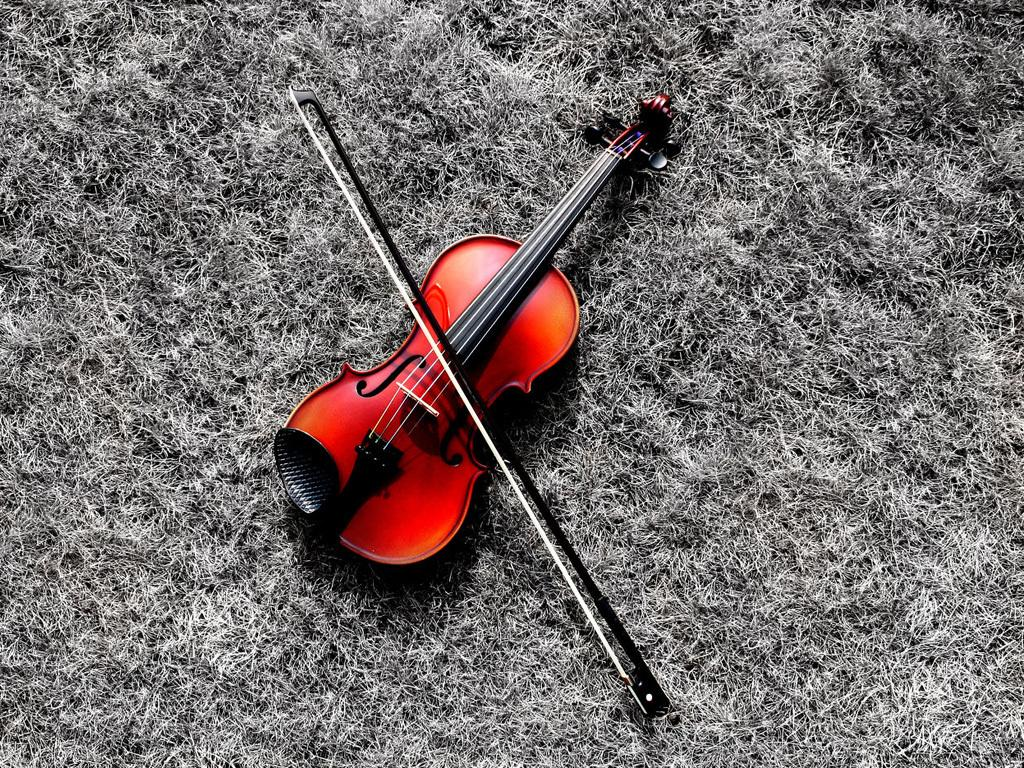What type of object is the main subject in the image? There is a musical instrument in the image. How many boys are playing the musical instrument in the image? There is no boy present in the image, and the musical instrument is not being played. 